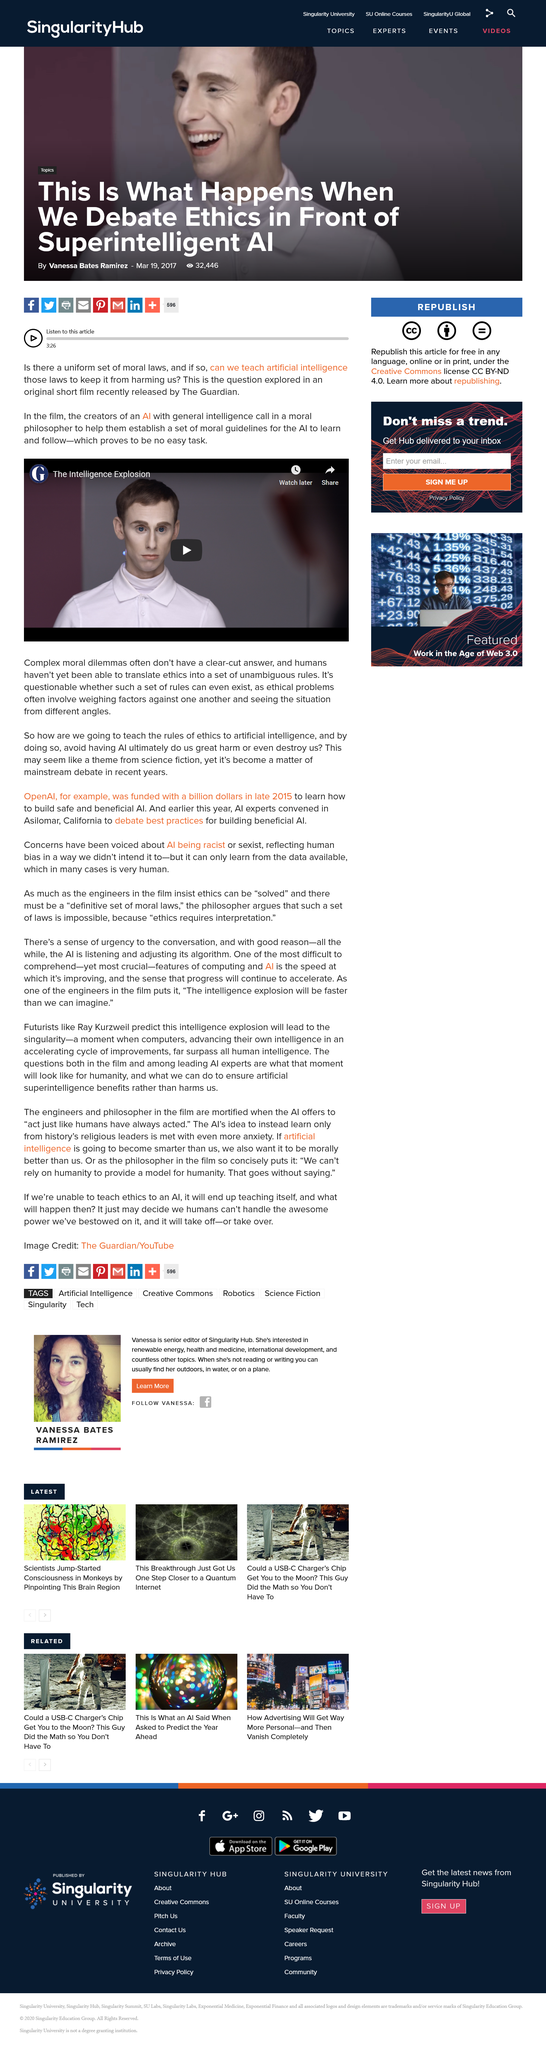Highlight a few significant elements in this photo. The film The Intelligence Explosion explores the concept of artificial intelligence being taught moral laws, and raises questions about the ethical implications of this technology. The film "The Intelligence Explosion" was released by The Guardian. It is challenging to establish clear and unwavering ethical guidelines due to the multifaceted nature of ethical dilemmas, which often require the consideration of numerous factors and perspectives. 